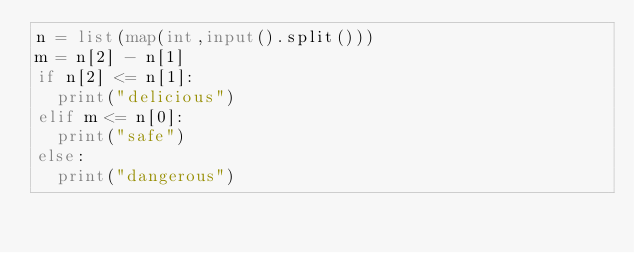<code> <loc_0><loc_0><loc_500><loc_500><_Python_>n = list(map(int,input().split()))
m = n[2] - n[1]
if n[2] <= n[1]:
  print("delicious")
elif m <= n[0]:
  print("safe")
else:
  print("dangerous")</code> 